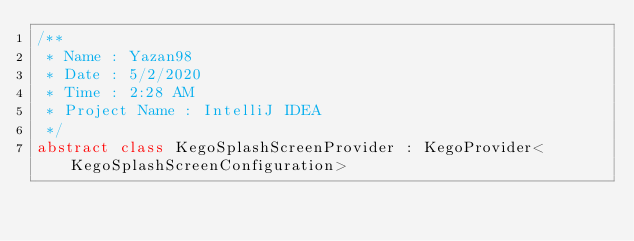Convert code to text. <code><loc_0><loc_0><loc_500><loc_500><_Kotlin_>/**
 * Name : Yazan98
 * Date : 5/2/2020
 * Time : 2:28 AM
 * Project Name : IntelliJ IDEA
 */
abstract class KegoSplashScreenProvider : KegoProvider<KegoSplashScreenConfiguration>
</code> 